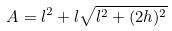Convert formula to latex. <formula><loc_0><loc_0><loc_500><loc_500>A = l ^ { 2 } + l \sqrt { l ^ { 2 } + ( 2 h ) ^ { 2 } }</formula> 